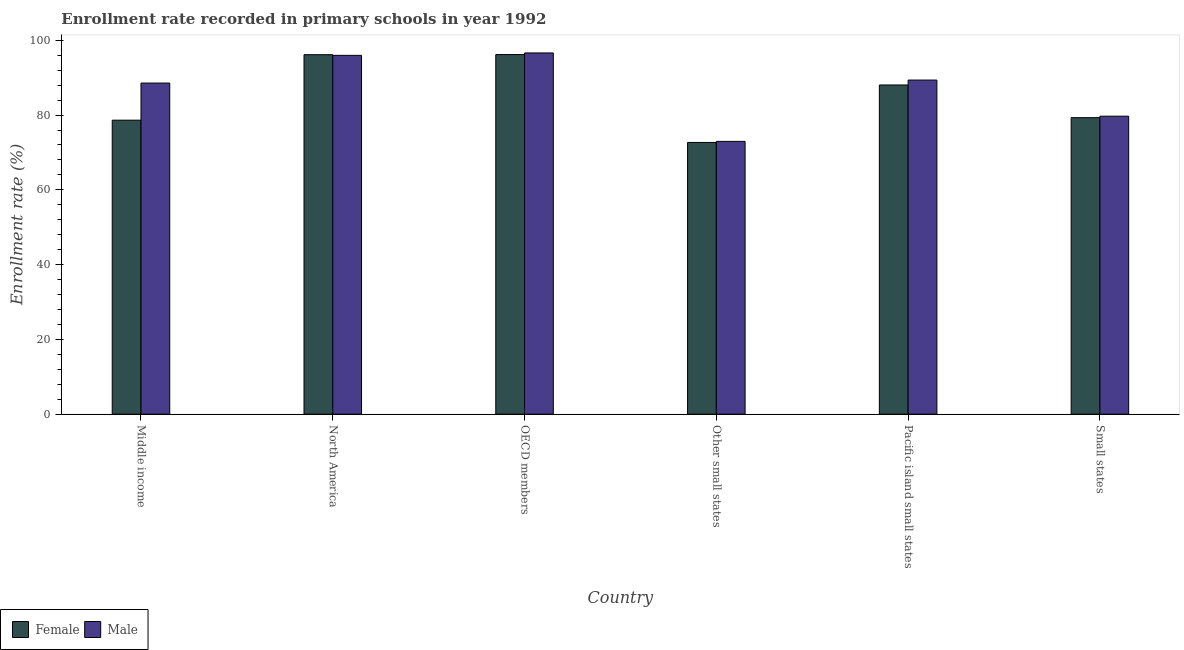How many different coloured bars are there?
Provide a succinct answer. 2. Are the number of bars per tick equal to the number of legend labels?
Your answer should be very brief. Yes. Are the number of bars on each tick of the X-axis equal?
Your answer should be compact. Yes. What is the label of the 5th group of bars from the left?
Your answer should be very brief. Pacific island small states. What is the enrollment rate of female students in OECD members?
Provide a succinct answer. 96.19. Across all countries, what is the maximum enrollment rate of female students?
Make the answer very short. 96.19. Across all countries, what is the minimum enrollment rate of male students?
Your answer should be compact. 72.96. In which country was the enrollment rate of female students maximum?
Your answer should be compact. OECD members. In which country was the enrollment rate of male students minimum?
Provide a short and direct response. Other small states. What is the total enrollment rate of female students in the graph?
Make the answer very short. 511.01. What is the difference between the enrollment rate of male students in Middle income and that in Pacific island small states?
Your response must be concise. -0.8. What is the difference between the enrollment rate of female students in Small states and the enrollment rate of male students in OECD members?
Keep it short and to the point. -17.31. What is the average enrollment rate of male students per country?
Provide a succinct answer. 87.2. What is the difference between the enrollment rate of male students and enrollment rate of female students in Pacific island small states?
Your response must be concise. 1.31. In how many countries, is the enrollment rate of female students greater than 76 %?
Ensure brevity in your answer.  5. What is the ratio of the enrollment rate of female students in North America to that in Pacific island small states?
Give a very brief answer. 1.09. Is the difference between the enrollment rate of male students in North America and Small states greater than the difference between the enrollment rate of female students in North America and Small states?
Your response must be concise. No. What is the difference between the highest and the second highest enrollment rate of male students?
Ensure brevity in your answer.  0.65. What is the difference between the highest and the lowest enrollment rate of male students?
Make the answer very short. 23.66. How many bars are there?
Provide a short and direct response. 12. Are all the bars in the graph horizontal?
Offer a terse response. No. What is the difference between two consecutive major ticks on the Y-axis?
Offer a terse response. 20. Are the values on the major ticks of Y-axis written in scientific E-notation?
Offer a terse response. No. How are the legend labels stacked?
Offer a terse response. Horizontal. What is the title of the graph?
Offer a terse response. Enrollment rate recorded in primary schools in year 1992. What is the label or title of the X-axis?
Provide a succinct answer. Country. What is the label or title of the Y-axis?
Offer a very short reply. Enrollment rate (%). What is the Enrollment rate (%) in Female in Middle income?
Offer a terse response. 78.64. What is the Enrollment rate (%) in Male in Middle income?
Offer a very short reply. 88.56. What is the Enrollment rate (%) of Female in North America?
Give a very brief answer. 96.15. What is the Enrollment rate (%) of Male in North America?
Ensure brevity in your answer.  95.97. What is the Enrollment rate (%) in Female in OECD members?
Your answer should be compact. 96.19. What is the Enrollment rate (%) of Male in OECD members?
Give a very brief answer. 96.62. What is the Enrollment rate (%) in Female in Other small states?
Your answer should be compact. 72.68. What is the Enrollment rate (%) of Male in Other small states?
Your response must be concise. 72.96. What is the Enrollment rate (%) in Female in Pacific island small states?
Keep it short and to the point. 88.05. What is the Enrollment rate (%) in Male in Pacific island small states?
Offer a very short reply. 89.36. What is the Enrollment rate (%) of Female in Small states?
Your answer should be compact. 79.31. What is the Enrollment rate (%) in Male in Small states?
Offer a very short reply. 79.7. Across all countries, what is the maximum Enrollment rate (%) in Female?
Your answer should be very brief. 96.19. Across all countries, what is the maximum Enrollment rate (%) of Male?
Your answer should be compact. 96.62. Across all countries, what is the minimum Enrollment rate (%) in Female?
Offer a terse response. 72.68. Across all countries, what is the minimum Enrollment rate (%) of Male?
Ensure brevity in your answer.  72.96. What is the total Enrollment rate (%) of Female in the graph?
Your response must be concise. 511.01. What is the total Enrollment rate (%) in Male in the graph?
Your response must be concise. 523.19. What is the difference between the Enrollment rate (%) of Female in Middle income and that in North America?
Offer a terse response. -17.51. What is the difference between the Enrollment rate (%) of Male in Middle income and that in North America?
Offer a terse response. -7.41. What is the difference between the Enrollment rate (%) in Female in Middle income and that in OECD members?
Give a very brief answer. -17.55. What is the difference between the Enrollment rate (%) of Male in Middle income and that in OECD members?
Keep it short and to the point. -8.06. What is the difference between the Enrollment rate (%) in Female in Middle income and that in Other small states?
Make the answer very short. 5.95. What is the difference between the Enrollment rate (%) in Male in Middle income and that in Other small states?
Offer a terse response. 15.6. What is the difference between the Enrollment rate (%) in Female in Middle income and that in Pacific island small states?
Offer a terse response. -9.42. What is the difference between the Enrollment rate (%) in Male in Middle income and that in Pacific island small states?
Give a very brief answer. -0.8. What is the difference between the Enrollment rate (%) of Female in Middle income and that in Small states?
Offer a very short reply. -0.67. What is the difference between the Enrollment rate (%) of Male in Middle income and that in Small states?
Your answer should be very brief. 8.86. What is the difference between the Enrollment rate (%) of Female in North America and that in OECD members?
Your answer should be compact. -0.04. What is the difference between the Enrollment rate (%) in Male in North America and that in OECD members?
Your answer should be compact. -0.65. What is the difference between the Enrollment rate (%) of Female in North America and that in Other small states?
Give a very brief answer. 23.47. What is the difference between the Enrollment rate (%) in Male in North America and that in Other small states?
Offer a very short reply. 23.01. What is the difference between the Enrollment rate (%) of Female in North America and that in Pacific island small states?
Make the answer very short. 8.1. What is the difference between the Enrollment rate (%) of Male in North America and that in Pacific island small states?
Ensure brevity in your answer.  6.61. What is the difference between the Enrollment rate (%) of Female in North America and that in Small states?
Provide a short and direct response. 16.84. What is the difference between the Enrollment rate (%) of Male in North America and that in Small states?
Ensure brevity in your answer.  16.28. What is the difference between the Enrollment rate (%) of Female in OECD members and that in Other small states?
Your answer should be compact. 23.51. What is the difference between the Enrollment rate (%) of Male in OECD members and that in Other small states?
Offer a terse response. 23.66. What is the difference between the Enrollment rate (%) in Female in OECD members and that in Pacific island small states?
Ensure brevity in your answer.  8.13. What is the difference between the Enrollment rate (%) of Male in OECD members and that in Pacific island small states?
Provide a succinct answer. 7.26. What is the difference between the Enrollment rate (%) of Female in OECD members and that in Small states?
Offer a terse response. 16.88. What is the difference between the Enrollment rate (%) in Male in OECD members and that in Small states?
Offer a very short reply. 16.92. What is the difference between the Enrollment rate (%) of Female in Other small states and that in Pacific island small states?
Your answer should be compact. -15.37. What is the difference between the Enrollment rate (%) in Male in Other small states and that in Pacific island small states?
Provide a short and direct response. -16.4. What is the difference between the Enrollment rate (%) of Female in Other small states and that in Small states?
Your answer should be compact. -6.63. What is the difference between the Enrollment rate (%) of Male in Other small states and that in Small states?
Your answer should be very brief. -6.74. What is the difference between the Enrollment rate (%) of Female in Pacific island small states and that in Small states?
Provide a succinct answer. 8.75. What is the difference between the Enrollment rate (%) in Male in Pacific island small states and that in Small states?
Provide a short and direct response. 9.66. What is the difference between the Enrollment rate (%) of Female in Middle income and the Enrollment rate (%) of Male in North America?
Give a very brief answer. -17.34. What is the difference between the Enrollment rate (%) in Female in Middle income and the Enrollment rate (%) in Male in OECD members?
Make the answer very short. -17.99. What is the difference between the Enrollment rate (%) of Female in Middle income and the Enrollment rate (%) of Male in Other small states?
Make the answer very short. 5.67. What is the difference between the Enrollment rate (%) in Female in Middle income and the Enrollment rate (%) in Male in Pacific island small states?
Your answer should be compact. -10.73. What is the difference between the Enrollment rate (%) in Female in Middle income and the Enrollment rate (%) in Male in Small states?
Provide a succinct answer. -1.06. What is the difference between the Enrollment rate (%) in Female in North America and the Enrollment rate (%) in Male in OECD members?
Provide a short and direct response. -0.47. What is the difference between the Enrollment rate (%) of Female in North America and the Enrollment rate (%) of Male in Other small states?
Provide a short and direct response. 23.19. What is the difference between the Enrollment rate (%) of Female in North America and the Enrollment rate (%) of Male in Pacific island small states?
Ensure brevity in your answer.  6.79. What is the difference between the Enrollment rate (%) in Female in North America and the Enrollment rate (%) in Male in Small states?
Your answer should be very brief. 16.45. What is the difference between the Enrollment rate (%) in Female in OECD members and the Enrollment rate (%) in Male in Other small states?
Offer a terse response. 23.22. What is the difference between the Enrollment rate (%) of Female in OECD members and the Enrollment rate (%) of Male in Pacific island small states?
Your answer should be very brief. 6.82. What is the difference between the Enrollment rate (%) of Female in OECD members and the Enrollment rate (%) of Male in Small states?
Ensure brevity in your answer.  16.49. What is the difference between the Enrollment rate (%) in Female in Other small states and the Enrollment rate (%) in Male in Pacific island small states?
Ensure brevity in your answer.  -16.68. What is the difference between the Enrollment rate (%) of Female in Other small states and the Enrollment rate (%) of Male in Small states?
Offer a terse response. -7.02. What is the difference between the Enrollment rate (%) of Female in Pacific island small states and the Enrollment rate (%) of Male in Small states?
Keep it short and to the point. 8.35. What is the average Enrollment rate (%) of Female per country?
Ensure brevity in your answer.  85.17. What is the average Enrollment rate (%) of Male per country?
Provide a short and direct response. 87.2. What is the difference between the Enrollment rate (%) of Female and Enrollment rate (%) of Male in Middle income?
Keep it short and to the point. -9.93. What is the difference between the Enrollment rate (%) of Female and Enrollment rate (%) of Male in North America?
Make the answer very short. 0.17. What is the difference between the Enrollment rate (%) in Female and Enrollment rate (%) in Male in OECD members?
Provide a short and direct response. -0.43. What is the difference between the Enrollment rate (%) in Female and Enrollment rate (%) in Male in Other small states?
Your response must be concise. -0.28. What is the difference between the Enrollment rate (%) in Female and Enrollment rate (%) in Male in Pacific island small states?
Your response must be concise. -1.31. What is the difference between the Enrollment rate (%) of Female and Enrollment rate (%) of Male in Small states?
Your answer should be compact. -0.39. What is the ratio of the Enrollment rate (%) of Female in Middle income to that in North America?
Your answer should be compact. 0.82. What is the ratio of the Enrollment rate (%) in Male in Middle income to that in North America?
Provide a succinct answer. 0.92. What is the ratio of the Enrollment rate (%) of Female in Middle income to that in OECD members?
Provide a succinct answer. 0.82. What is the ratio of the Enrollment rate (%) of Male in Middle income to that in OECD members?
Your answer should be compact. 0.92. What is the ratio of the Enrollment rate (%) of Female in Middle income to that in Other small states?
Your answer should be compact. 1.08. What is the ratio of the Enrollment rate (%) of Male in Middle income to that in Other small states?
Your response must be concise. 1.21. What is the ratio of the Enrollment rate (%) of Female in Middle income to that in Pacific island small states?
Offer a terse response. 0.89. What is the ratio of the Enrollment rate (%) of Female in Middle income to that in Small states?
Provide a succinct answer. 0.99. What is the ratio of the Enrollment rate (%) of Male in Middle income to that in Small states?
Ensure brevity in your answer.  1.11. What is the ratio of the Enrollment rate (%) of Female in North America to that in OECD members?
Your answer should be very brief. 1. What is the ratio of the Enrollment rate (%) in Male in North America to that in OECD members?
Give a very brief answer. 0.99. What is the ratio of the Enrollment rate (%) in Female in North America to that in Other small states?
Keep it short and to the point. 1.32. What is the ratio of the Enrollment rate (%) of Male in North America to that in Other small states?
Your response must be concise. 1.32. What is the ratio of the Enrollment rate (%) in Female in North America to that in Pacific island small states?
Give a very brief answer. 1.09. What is the ratio of the Enrollment rate (%) in Male in North America to that in Pacific island small states?
Make the answer very short. 1.07. What is the ratio of the Enrollment rate (%) of Female in North America to that in Small states?
Your response must be concise. 1.21. What is the ratio of the Enrollment rate (%) in Male in North America to that in Small states?
Keep it short and to the point. 1.2. What is the ratio of the Enrollment rate (%) in Female in OECD members to that in Other small states?
Make the answer very short. 1.32. What is the ratio of the Enrollment rate (%) in Male in OECD members to that in Other small states?
Keep it short and to the point. 1.32. What is the ratio of the Enrollment rate (%) of Female in OECD members to that in Pacific island small states?
Your answer should be very brief. 1.09. What is the ratio of the Enrollment rate (%) in Male in OECD members to that in Pacific island small states?
Your response must be concise. 1.08. What is the ratio of the Enrollment rate (%) of Female in OECD members to that in Small states?
Provide a short and direct response. 1.21. What is the ratio of the Enrollment rate (%) in Male in OECD members to that in Small states?
Give a very brief answer. 1.21. What is the ratio of the Enrollment rate (%) of Female in Other small states to that in Pacific island small states?
Offer a very short reply. 0.83. What is the ratio of the Enrollment rate (%) of Male in Other small states to that in Pacific island small states?
Provide a succinct answer. 0.82. What is the ratio of the Enrollment rate (%) in Female in Other small states to that in Small states?
Your answer should be very brief. 0.92. What is the ratio of the Enrollment rate (%) in Male in Other small states to that in Small states?
Your answer should be compact. 0.92. What is the ratio of the Enrollment rate (%) of Female in Pacific island small states to that in Small states?
Your response must be concise. 1.11. What is the ratio of the Enrollment rate (%) of Male in Pacific island small states to that in Small states?
Make the answer very short. 1.12. What is the difference between the highest and the second highest Enrollment rate (%) of Female?
Your answer should be compact. 0.04. What is the difference between the highest and the second highest Enrollment rate (%) of Male?
Offer a very short reply. 0.65. What is the difference between the highest and the lowest Enrollment rate (%) in Female?
Offer a very short reply. 23.51. What is the difference between the highest and the lowest Enrollment rate (%) in Male?
Offer a terse response. 23.66. 